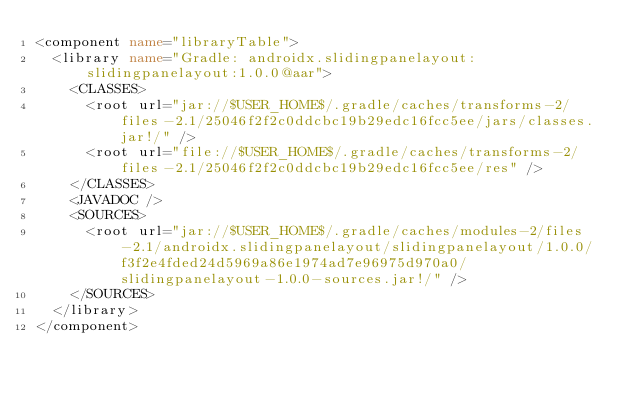Convert code to text. <code><loc_0><loc_0><loc_500><loc_500><_XML_><component name="libraryTable">
  <library name="Gradle: androidx.slidingpanelayout:slidingpanelayout:1.0.0@aar">
    <CLASSES>
      <root url="jar://$USER_HOME$/.gradle/caches/transforms-2/files-2.1/25046f2f2c0ddcbc19b29edc16fcc5ee/jars/classes.jar!/" />
      <root url="file://$USER_HOME$/.gradle/caches/transforms-2/files-2.1/25046f2f2c0ddcbc19b29edc16fcc5ee/res" />
    </CLASSES>
    <JAVADOC />
    <SOURCES>
      <root url="jar://$USER_HOME$/.gradle/caches/modules-2/files-2.1/androidx.slidingpanelayout/slidingpanelayout/1.0.0/f3f2e4fded24d5969a86e1974ad7e96975d970a0/slidingpanelayout-1.0.0-sources.jar!/" />
    </SOURCES>
  </library>
</component></code> 